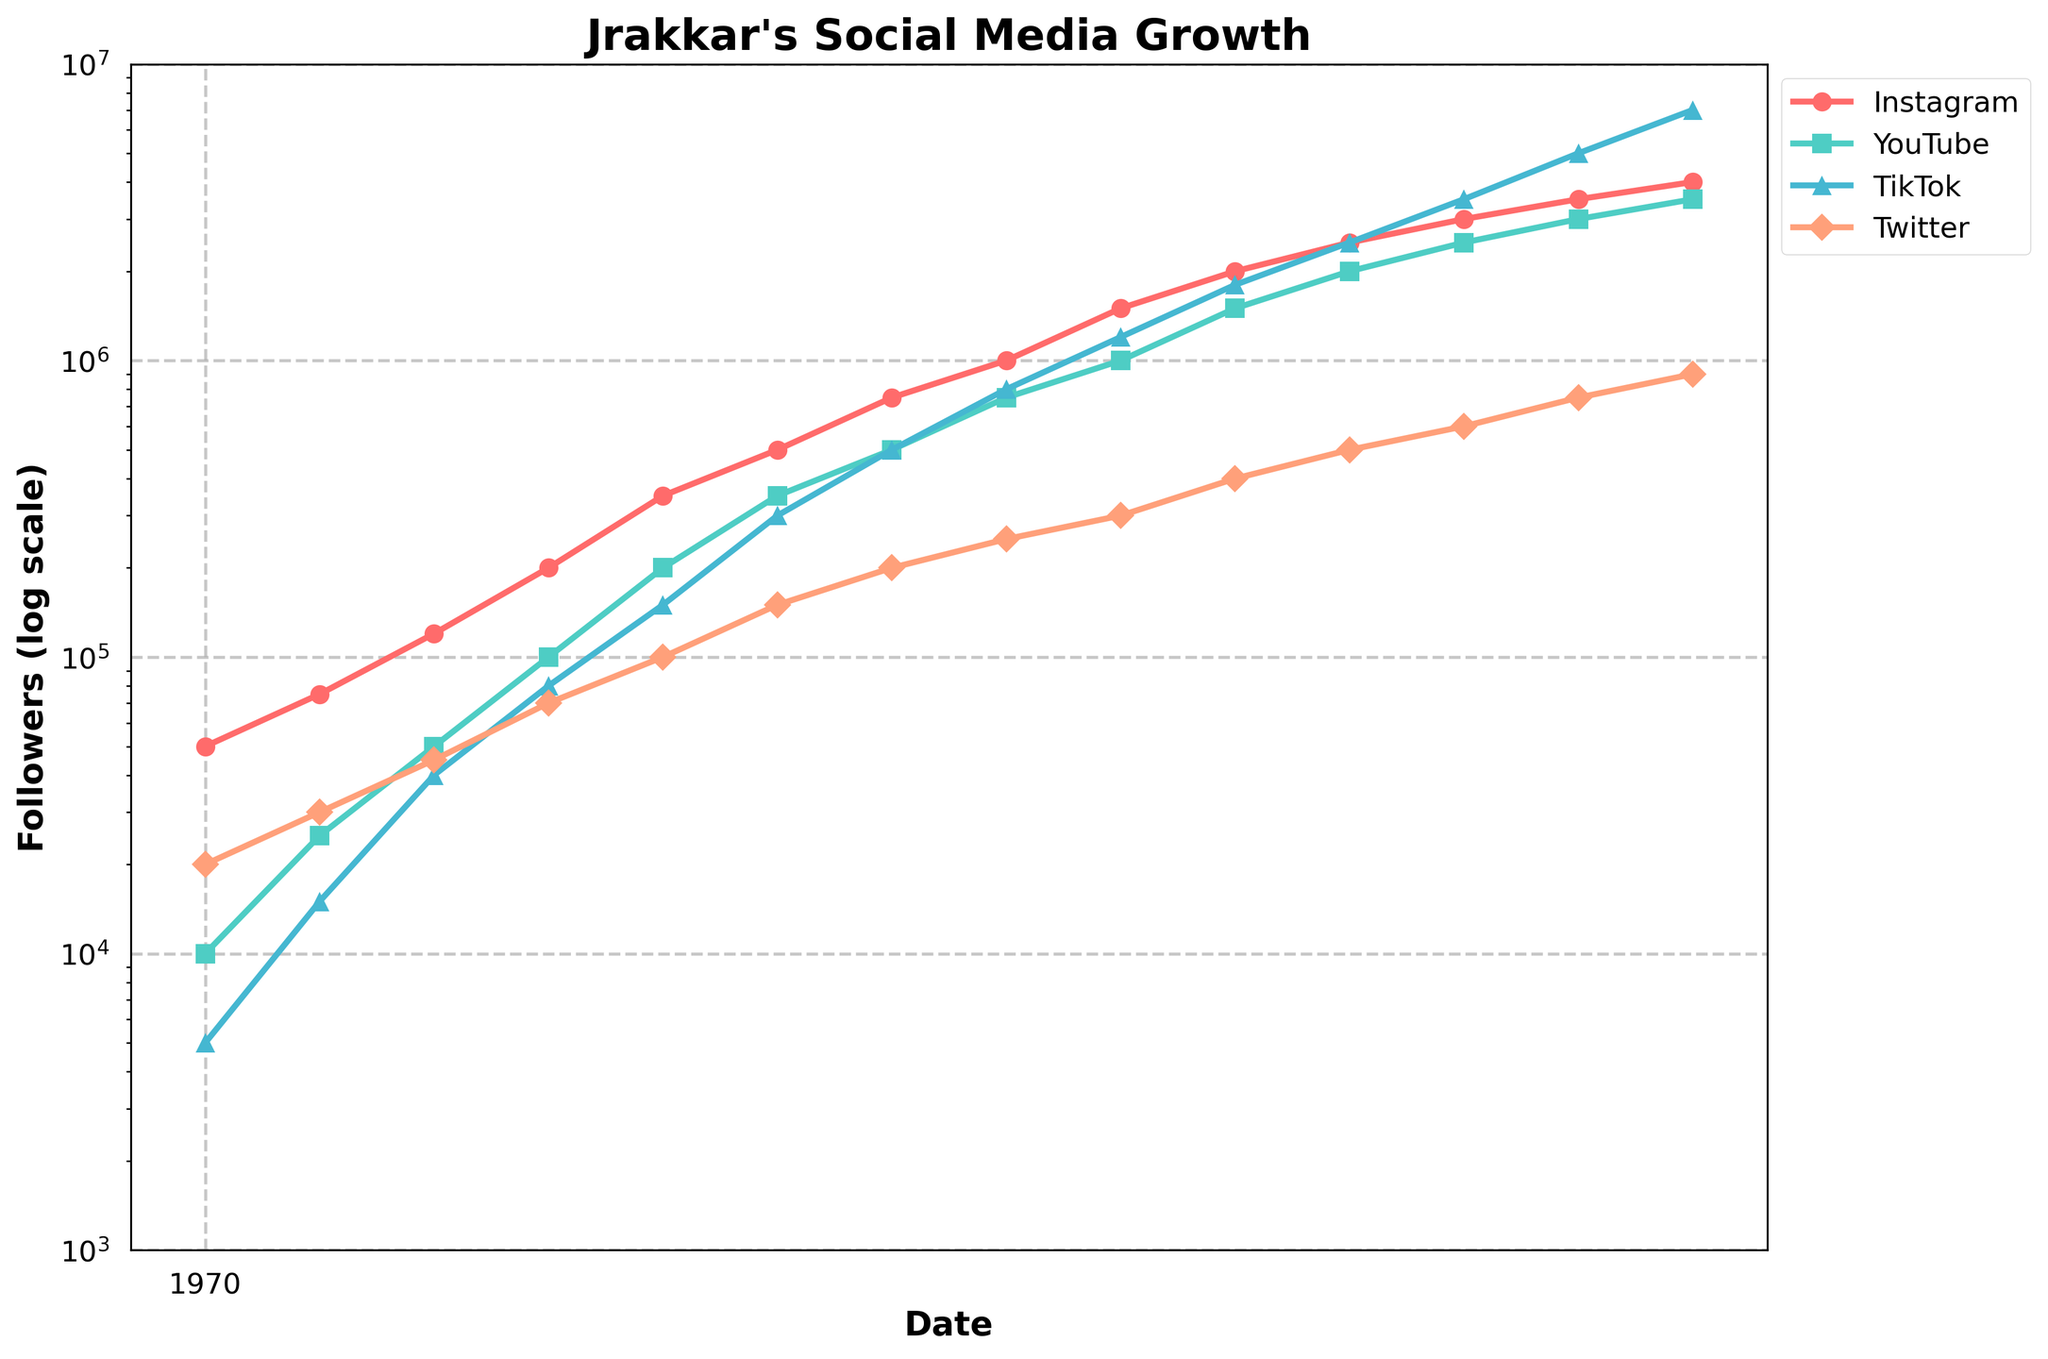What is the follower count growth for TikTok from January 2020 to April 2023? Start with TikTok follower count on January 2020 (5000) and subtract it from the follower count on April 2023 (7000000). Thus, 7000000 - 5000
Answer: 6995000 Which social media platform had the most followers as of April 2023? Observing the plot, TikTok has the highest follower count in April 2023 compared to Instagram, YouTube, and Twitter
Answer: TikTok Between October 2022 and January 2023, which platform experienced the most significant growth in follower count? Check the difference in follower counts for each platform between October 2022 and January 2023: 
- Instagram: 3500000 - 3000000 = 500000
- YouTube: 3000000 - 2500000 = 500000
- TikTok: 5000000 - 3500000 = 1500000
- Twitter: 750000 - 600000 = 150000. The highest change is for TikTok
Answer: TikTok By how many times did Jrakkar's YouTube followers increase from January 2020 to July 2021? Initial YouTube followers in January 2020 are 10000, and in July 2021, they are 500000. The ratio of increase is 500000 / 10000 = 50 times
Answer: 50 times As of January 2021, what was the total combined follower count across all four platforms? Summing up the follower counts from January 2021 for all platforms: 
- Instagram: 350000
- YouTube: 200000
- TikTok: 150000
- Twitter: 100000 resulting in 350000 + 200000 + 150000 + 100000 = 800000
Answer: 800000 Which platform showed a steadier growth pattern from 2020 to 2023? By visually comparing the steepness and consistency of the lines, Instagram appears to have a steadier upward trend without major fluctuations
Answer: Instagram What was the average follower count on Twitter across all time points displayed in the figure? Add Twitter follower counts across all dates and divide by the number of dates (14 points):
(20000 + 30000 + 45000 + 70000 + 100000 + 150000 + 200000 + 250000 + 300000 + 400000 + 500000 + 600000 + 750000 + 900000) / 14 = 367142.86
Answer: 367142.86 How does the growth rate of Instagram compare to YouTube between July 2020 and January 2022? Calculate growth rates:
- Instagram: (1500000 - 120000) / 120000 = 11.5 times
- YouTube: (1000000 - 50000) / 50000 = 19 times. YouTube's growth rate is higher
Answer: YouTube Considering the log scale on the y-axis, which period shows the fastest growth for TikTok? The steepest angle of the TikTok line is between October 2022 and January 2023 indicating this period as the fastest growth
Answer: October 2022 - January 2023 